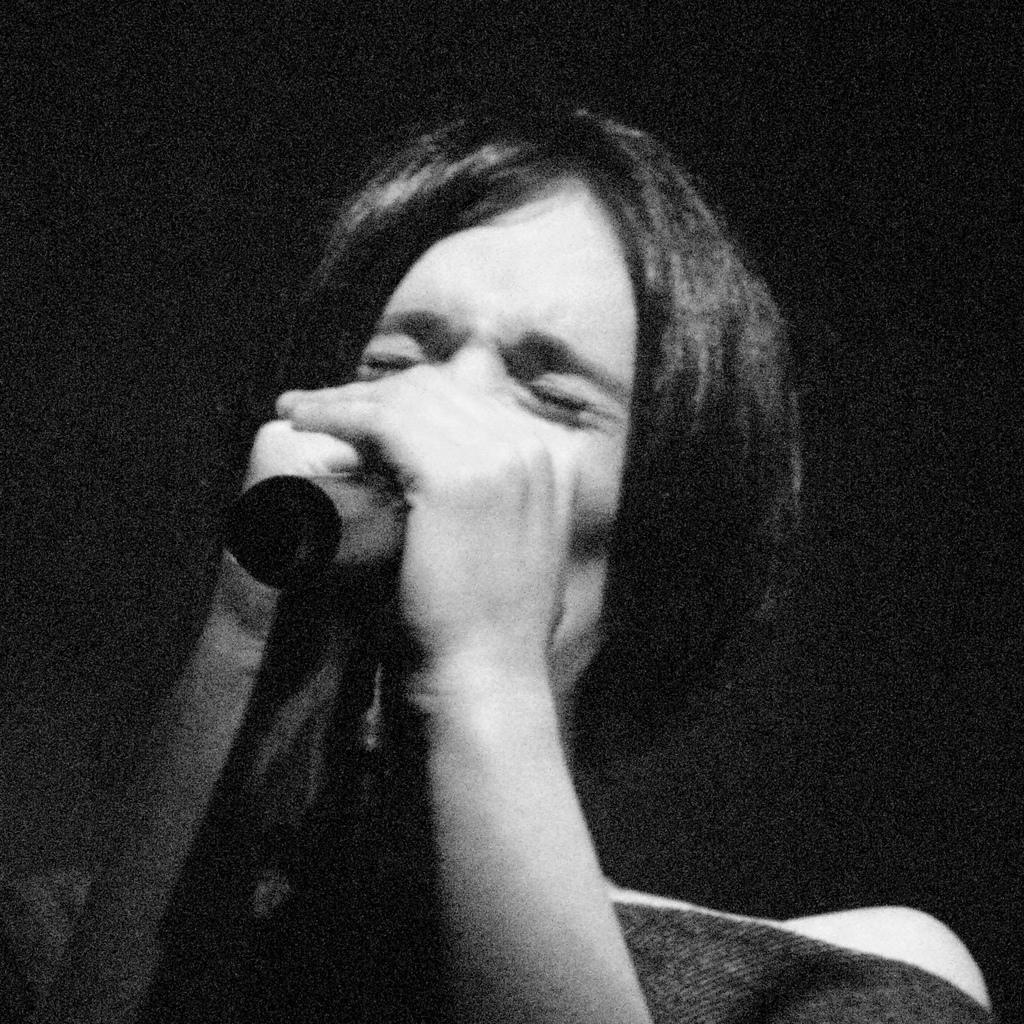What is the color scheme of the image? The image is black and white. Can you describe the person in the image? There is a person in the image. What is the person holding in their hands? The person is holding a microphone in their hands. What can be seen in the background of the image? The background of the image is dark. What type of crack can be seen in the image? There is no crack present in the image. Can you describe the vase in the image? There is no vase present in the image. 